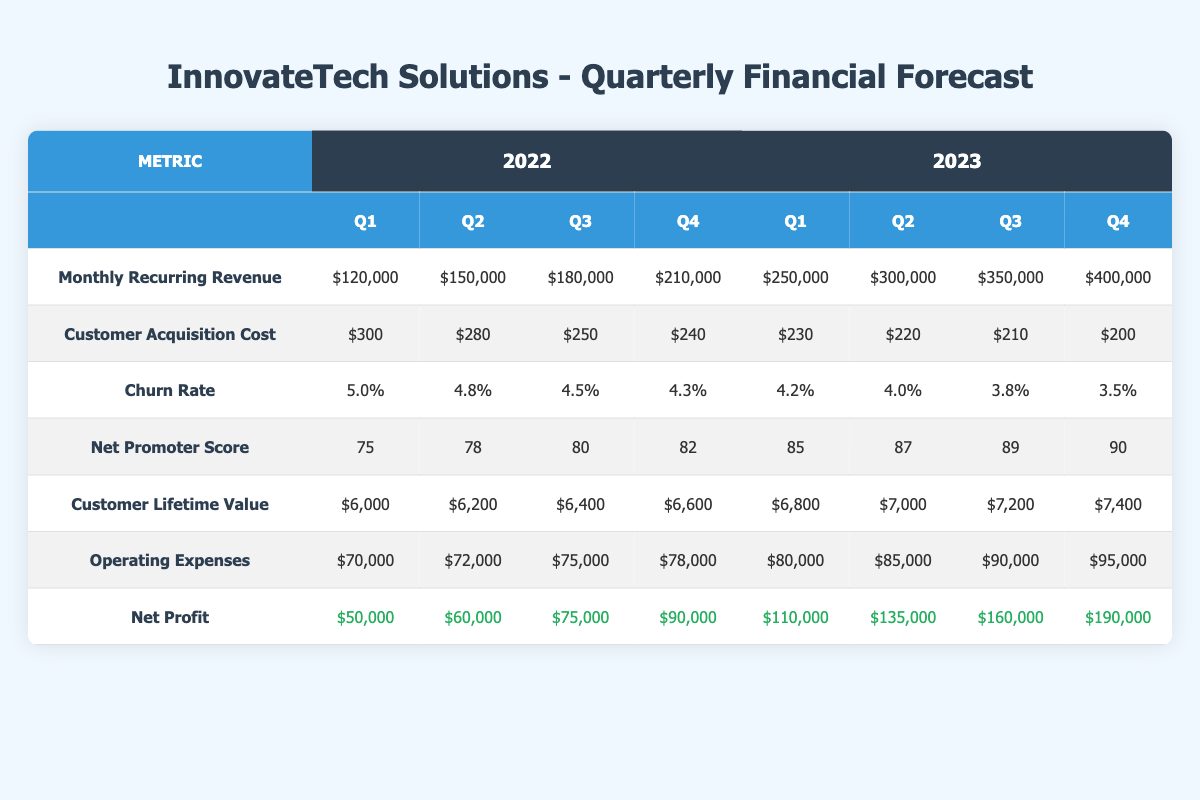What was the Monthly Recurring Revenue (MRR) in Q3 of 2023? In the Q3 column for the year 2023, the Monthly Recurring Revenue is listed as 350,000.
Answer: 350,000 What is the Customer Acquisition Cost (CAC) for Q4 of 2022? In the Q4 column for the year 2022, the Customer Acquisition Cost is listed as 240.
Answer: 240 Is the Churn Rate lower in Q1 of 2023 compared to Q4 of 2022? The Churn Rate for Q1 of 2023 is 4.2% and for Q4 of 2022 it is 4.3%. Since 4.2% is less than 4.3%, the Churn Rate is indeed lower.
Answer: Yes What was the highest Net Profit achieved in 2023? By looking at the Net Profit column for 2023, the highest amount is in Q4, which is 190,000.
Answer: 190,000 What is the average Customer Lifetime Value (CLV) for 2022? The Customer Lifetime Values for 2022 quarters are 6,000, 6,200, 6,400, and 6,600. The average is (6,000 + 6,200 + 6,400 + 6,600) / 4 = 6,300.
Answer: 6,300 Was there a consistent decrease in Customer Acquisition Cost from Q1 2022 to Q4 2023? Looking at the Customer Acquisition Cost values, they are 300, 280, 250, 240 for 2022 and 230, 220, 210, 200 for 2023. This shows a consistent decrease across all quarters.
Answer: Yes What is the total Net Profit generated in 2022? Summing the Net Profit for all quarters in 2022 gives us 50,000 + 60,000 + 75,000 + 90,000 = 275,000.
Answer: 275,000 Which quarter in 2023 had the best Net Promoter Score? Comparing the Net Promoter Scores for all quarters in 2023, Q4 has the highest score at 90.
Answer: Q4 2023 What was the change in Operating Expenses from Q1 of 2022 to Q4 of 2023? The Operating Expenses are 70,000 for Q1 2022 and 95,000 for Q4 2023. The change is 95,000 - 70,000 = 25,000, indicating an increase.
Answer: 25,000 increase Did the Monthly Recurring Revenue increase every quarter across both years? By reviewing the MRR for each quarter, it shows a consistent increase from Q1 to Q4 in both years.
Answer: Yes 